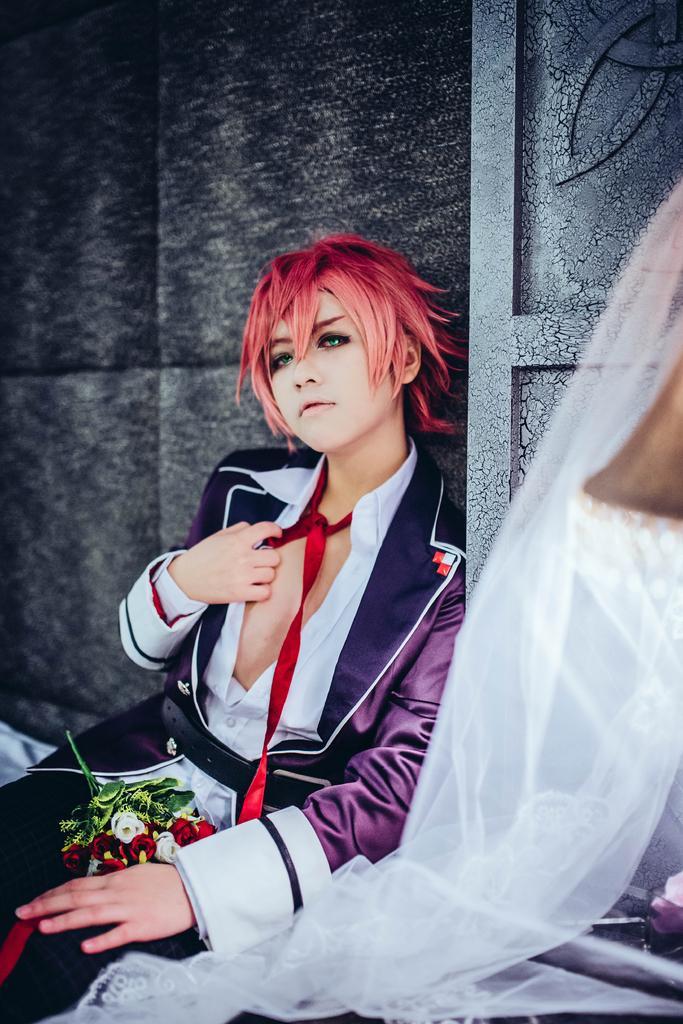Please provide a concise description of this image. In this image we can see a woman sitting. We can also see the roses. In the background we can see the wall. On the right we can see some white color net. 